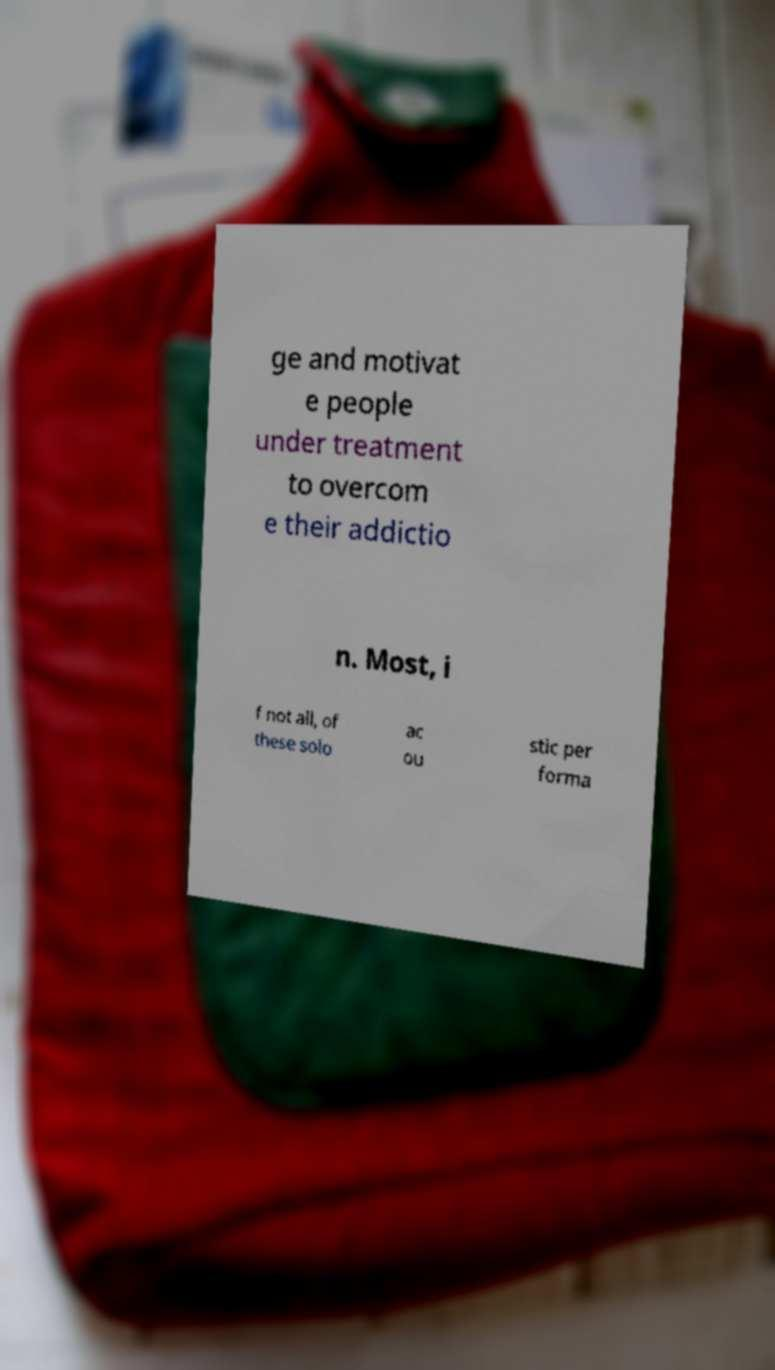What messages or text are displayed in this image? I need them in a readable, typed format. ge and motivat e people under treatment to overcom e their addictio n. Most, i f not all, of these solo ac ou stic per forma 